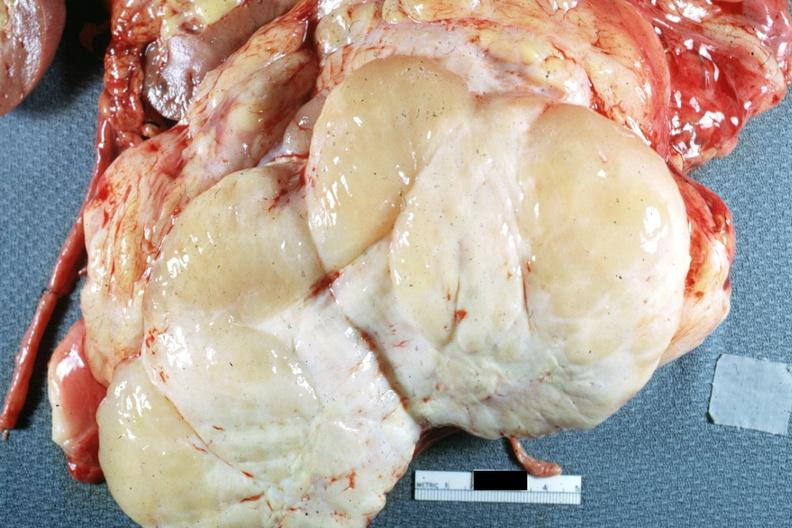s retroperitoneal liposarcoma present?
Answer the question using a single word or phrase. Yes 